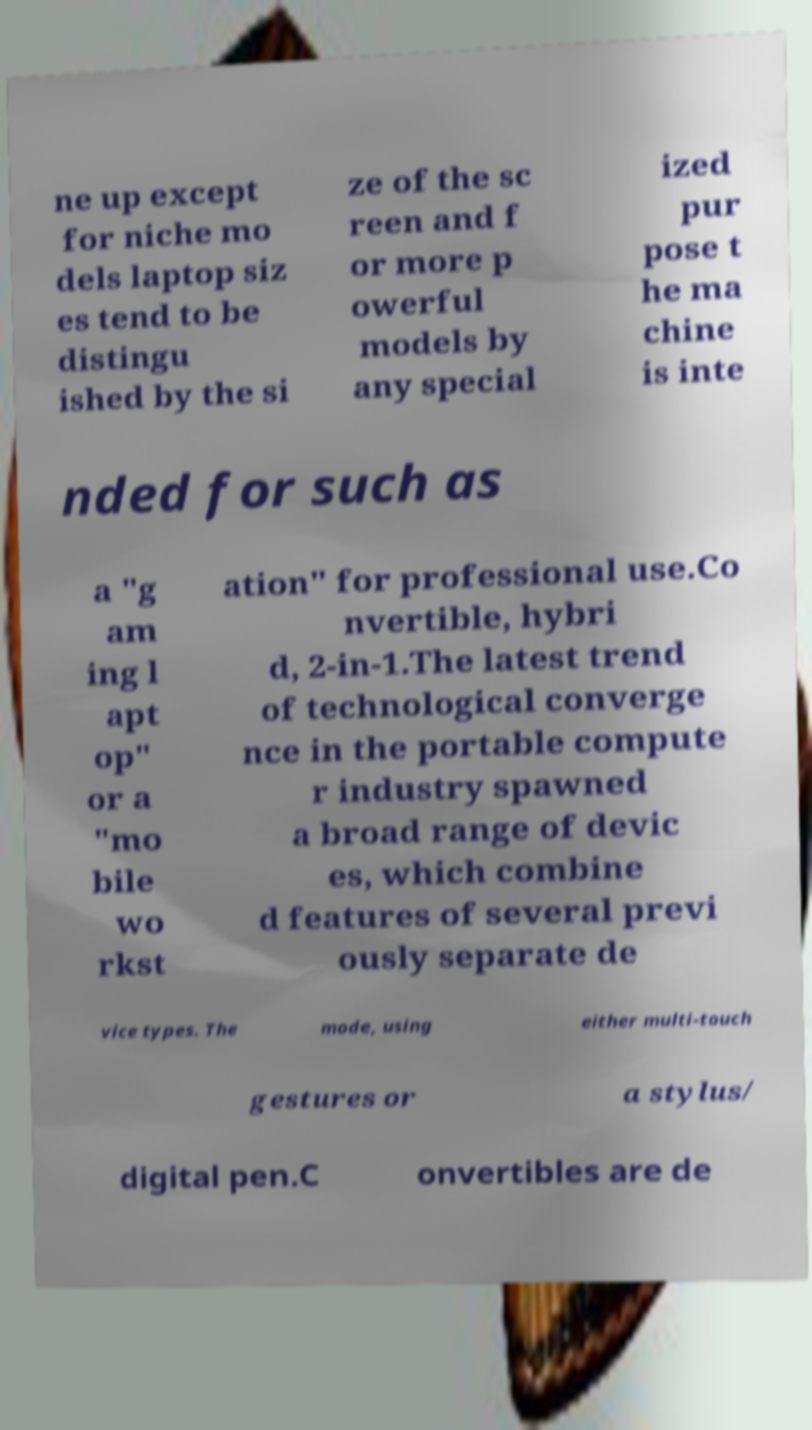What messages or text are displayed in this image? I need them in a readable, typed format. ne up except for niche mo dels laptop siz es tend to be distingu ished by the si ze of the sc reen and f or more p owerful models by any special ized pur pose t he ma chine is inte nded for such as a "g am ing l apt op" or a "mo bile wo rkst ation" for professional use.Co nvertible, hybri d, 2-in-1.The latest trend of technological converge nce in the portable compute r industry spawned a broad range of devic es, which combine d features of several previ ously separate de vice types. The mode, using either multi-touch gestures or a stylus/ digital pen.C onvertibles are de 